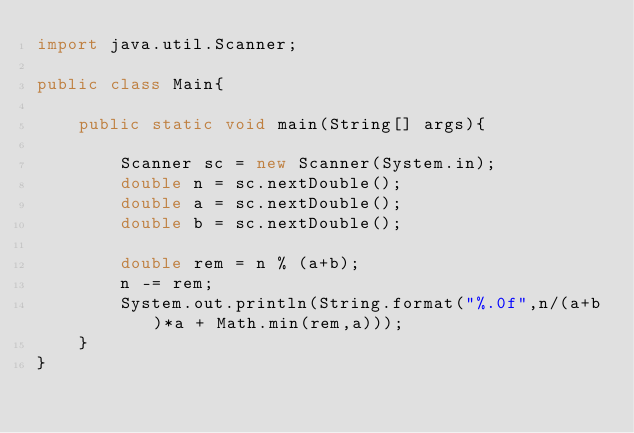Convert code to text. <code><loc_0><loc_0><loc_500><loc_500><_Java_>import java.util.Scanner;

public class Main{

    public static void main(String[] args){

        Scanner sc = new Scanner(System.in);
        double n = sc.nextDouble();
        double a = sc.nextDouble();
        double b = sc.nextDouble();

        double rem = n % (a+b);
        n -= rem;
        System.out.println(String.format("%.0f",n/(a+b)*a + Math.min(rem,a)));
    }
}
</code> 